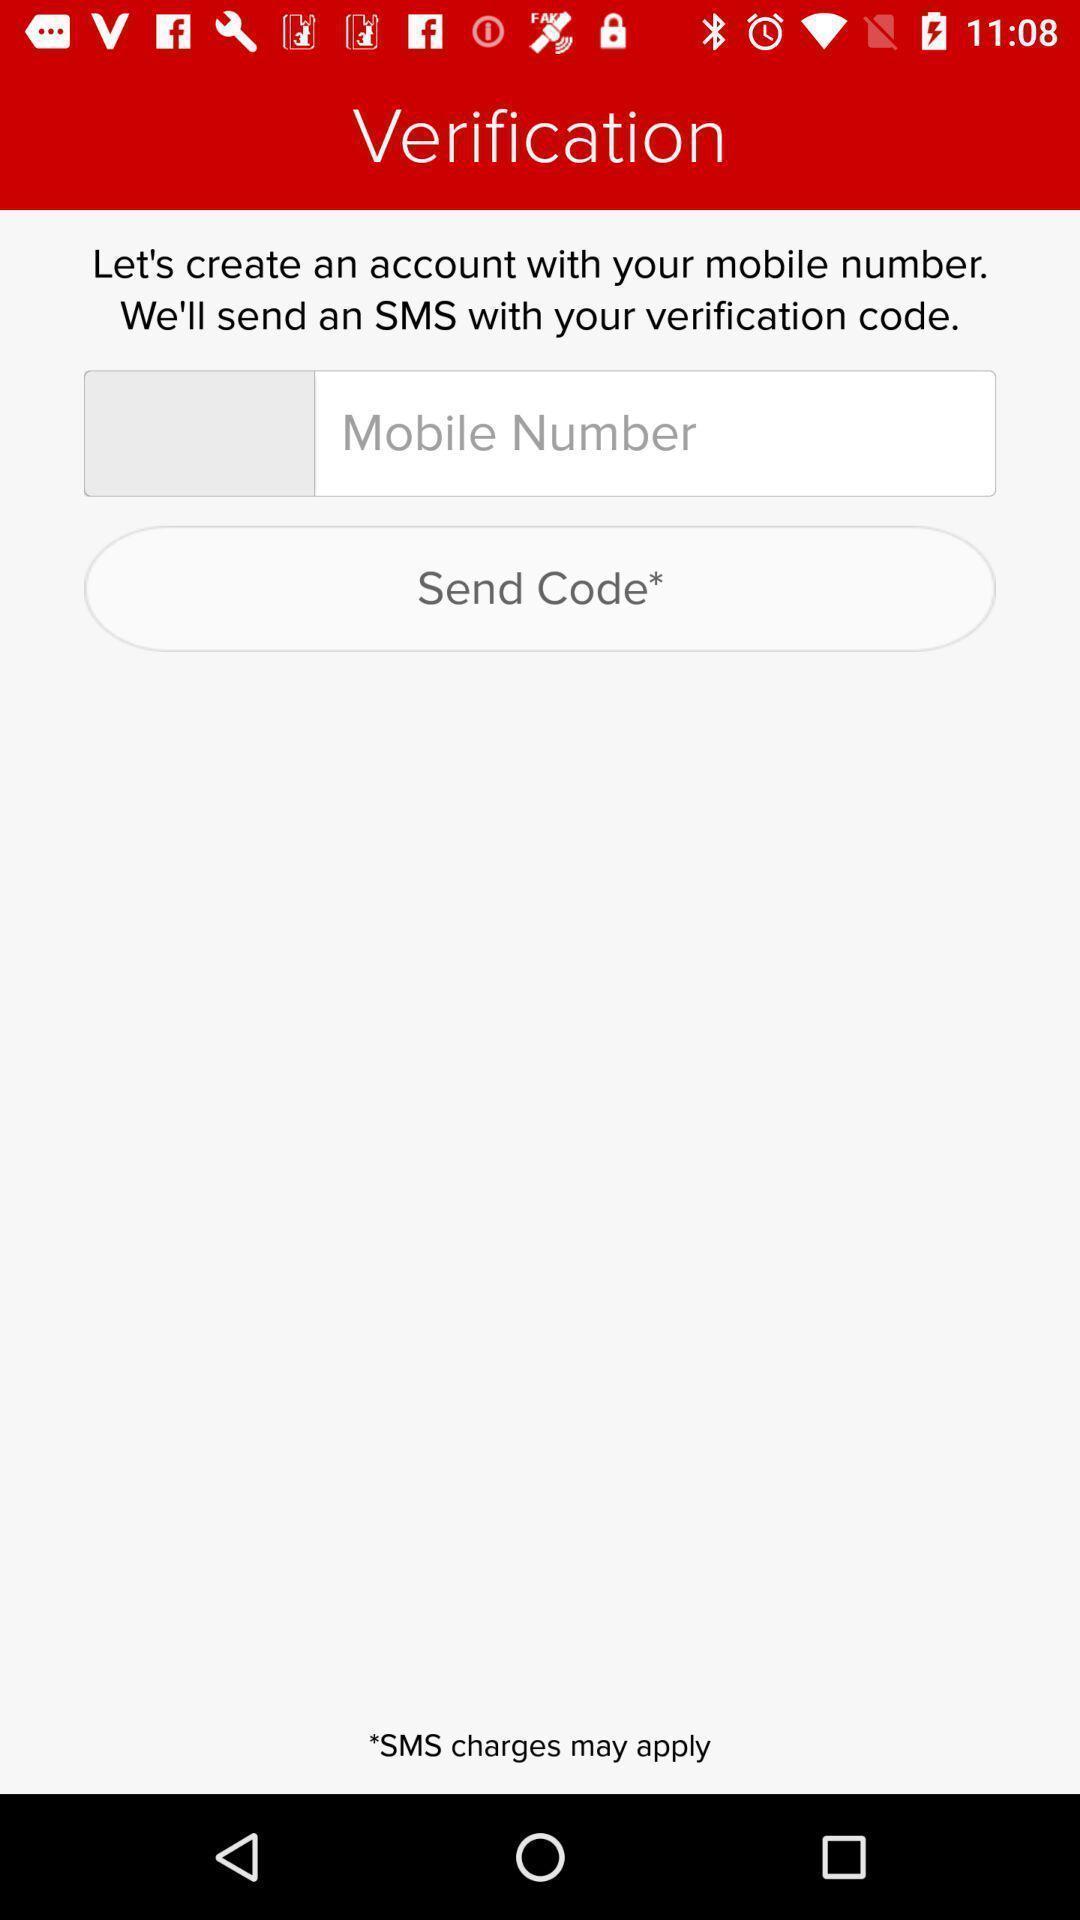What details can you identify in this image? Verification page of international calling app. 